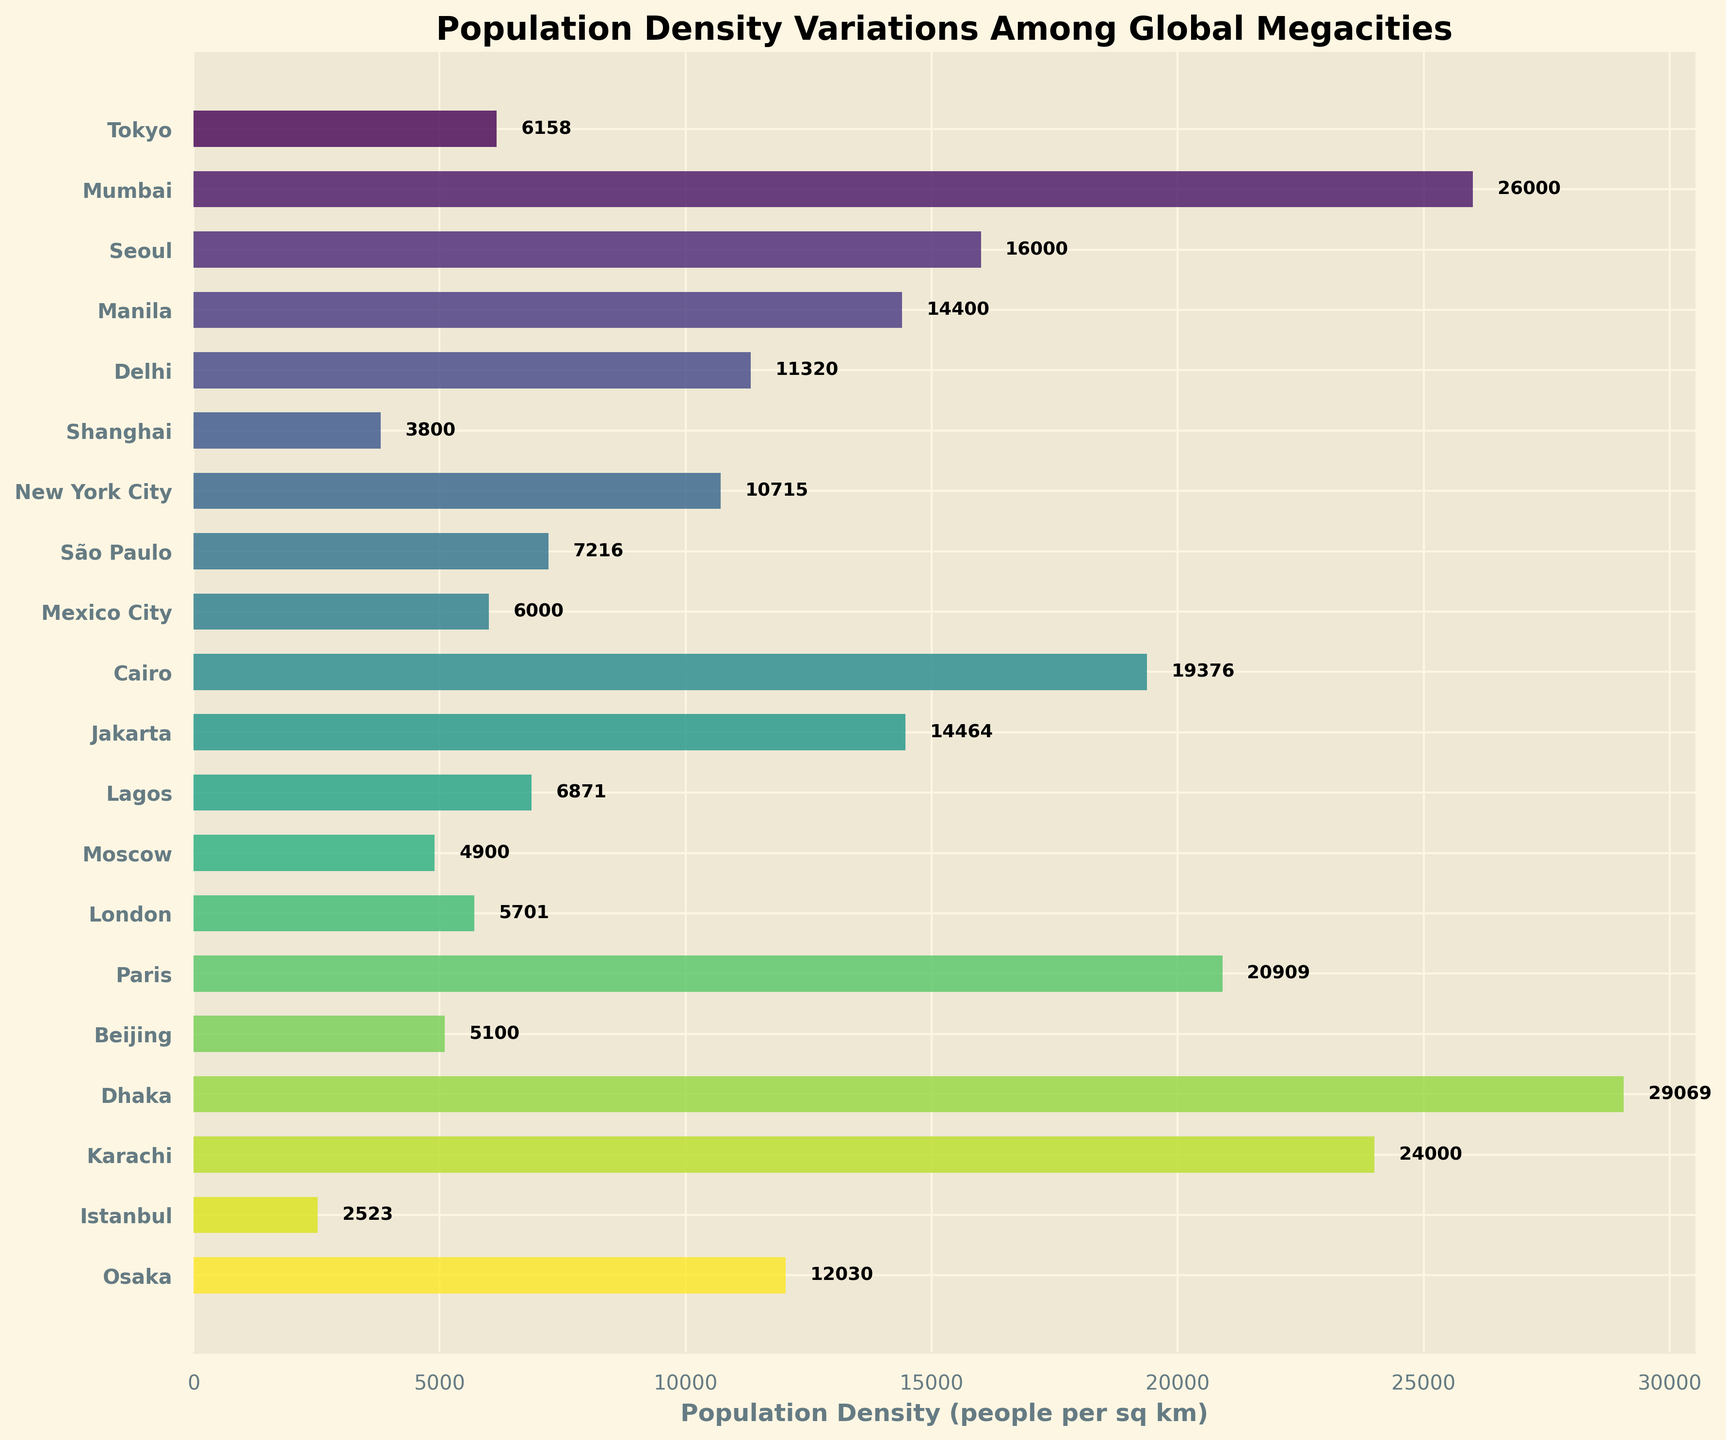What is the title of the figure? The title of the figure is located at the top of the plot and gives an overview of the data being visualized.
Answer: Population Density Variations Among Global Megacities Which city has the highest population density? Locate the bar that extends furthest to the right on the horizontal axis, which represents the highest population density.
Answer: Dhaka What is the population density of São Paulo? Find the bar labeled "São Paulo" on the y-axis, then check the length of the bar to find the corresponding value on the x-axis.
Answer: 7216 How many cities have a population density greater than 20,000 people per square kilometer? Count all the bars that have a value higher than 20,000 on the x-axis.
Answer: 3 Which city has a larger population density: Lagos or Moscow? Compare the lengths of the bars associated with Lagos and Moscow.
Answer: Lagos What is the total population density of Tokyo, Seoul, and Manila combined? Add the population densities of these three cities: Tokyo (6158), Seoul (16000), and Manila (14400).
Answer: 36558 How does the population density of Beijing compare to that of New York City? Check the bars for Beijing and New York City and compare their lengths.
Answer: New York City has a higher population density Between Istanbul and London, which city has a smaller population density, and by how much? Compare the bars for Istanbul and London and calculate the difference. London has a population density of 5701, and Istanbul has 2523. The difference is 5701 - 2523.
Answer: Istanbul, by 3178 What is the range of population densities represented in the plot? Find the difference between the highest and lowest population densities shown on the x-axis. Dhaka has the highest at 29069, and Istanbul has the lowest at 2523.
Answer: 26546 What is the median population density of the cities in the plot? Arrange the population densities in ascending order and find the middle value. The middle value (if odd) or the average of the two middle values (if even) is the median. The sorted values are 2523, 3800, 4900, 5100, 5701, 6000, 6158, 6871, 7216, 10715, 11320, 12030, 14400, 14464, 16000, 19376, 20909, 24000, 26000, 29069. The median is the average of the 10th and 11th values: (10715 + 11320) / 2.
Answer: 11017.5 